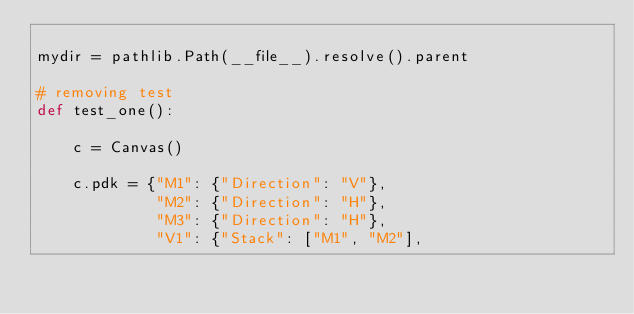Convert code to text. <code><loc_0><loc_0><loc_500><loc_500><_Python_>
mydir = pathlib.Path(__file__).resolve().parent

# removing test
def test_one():

    c = Canvas()

    c.pdk = {"M1": {"Direction": "V"},
             "M2": {"Direction": "H"},
             "M3": {"Direction": "H"},
             "V1": {"Stack": ["M1", "M2"],</code> 